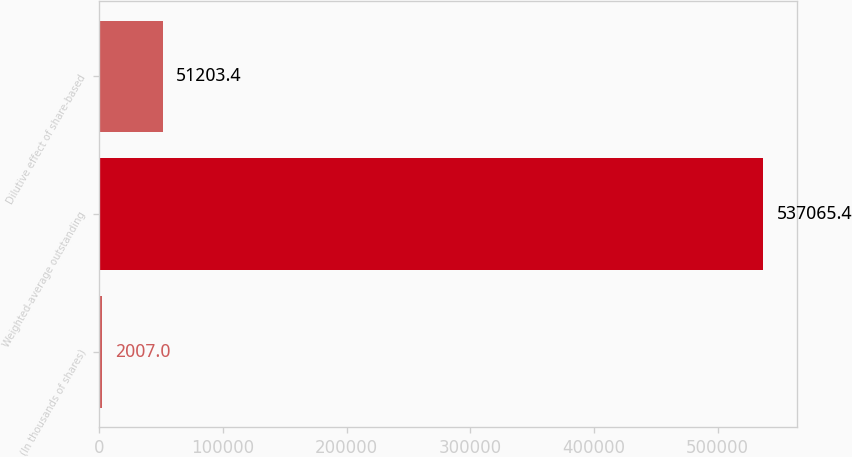Convert chart. <chart><loc_0><loc_0><loc_500><loc_500><bar_chart><fcel>(In thousands of shares)<fcel>Weighted-average outstanding<fcel>Dilutive effect of share-based<nl><fcel>2007<fcel>537065<fcel>51203.4<nl></chart> 